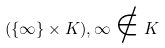Convert formula to latex. <formula><loc_0><loc_0><loc_500><loc_500>( \{ \infty \} \times K ) , \infty \notin K</formula> 